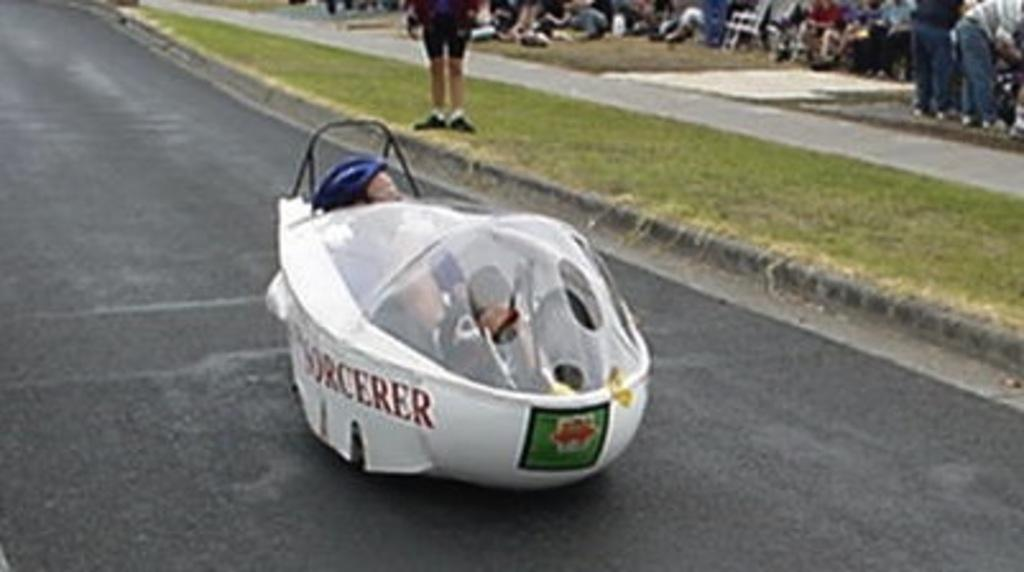What is the main subject of the image? There is a racing car in the center of the image. Can you describe the setting of the image? There are people in the background of the image, and there is a road at the bottom of the image. What type of news can be seen on the racing car in the image? There is no news present on the racing car in the image; it is a vehicle used for racing. 